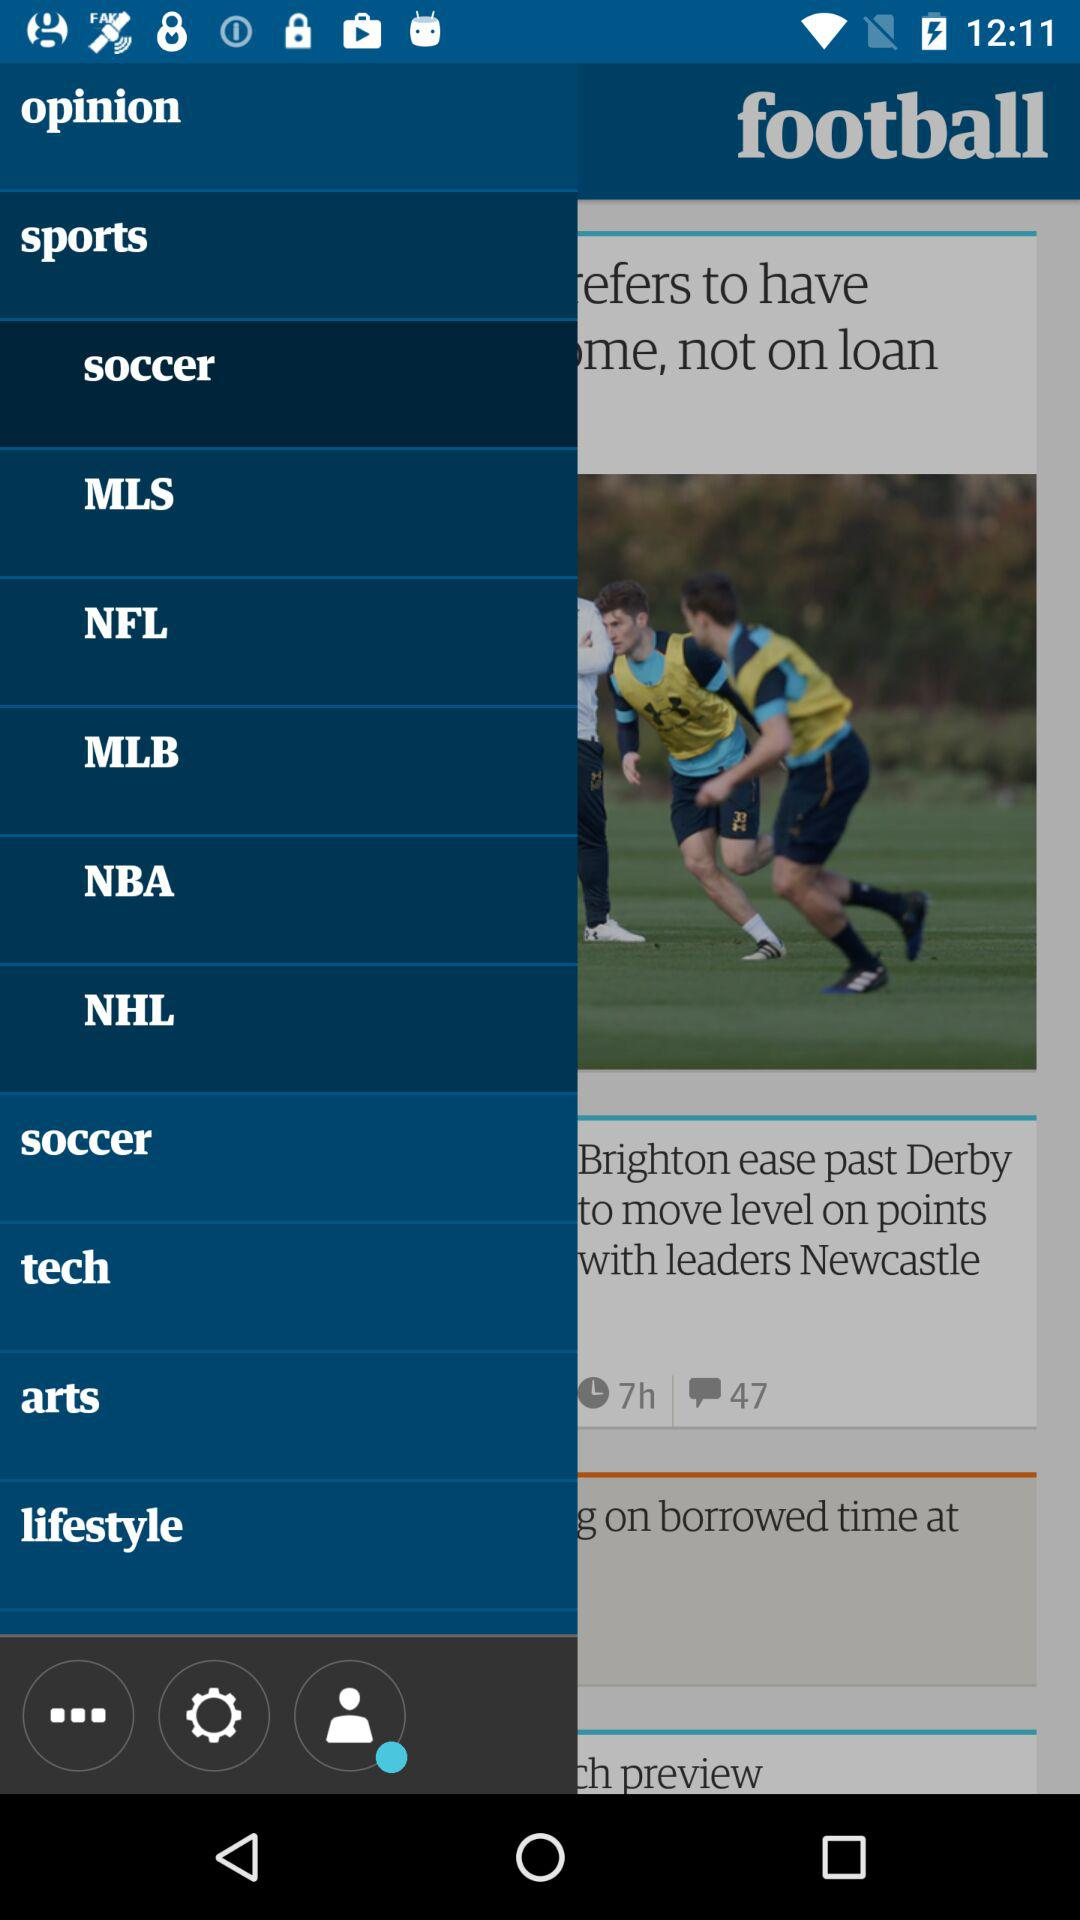What is the selected sport? The selected sport is "soccer". 